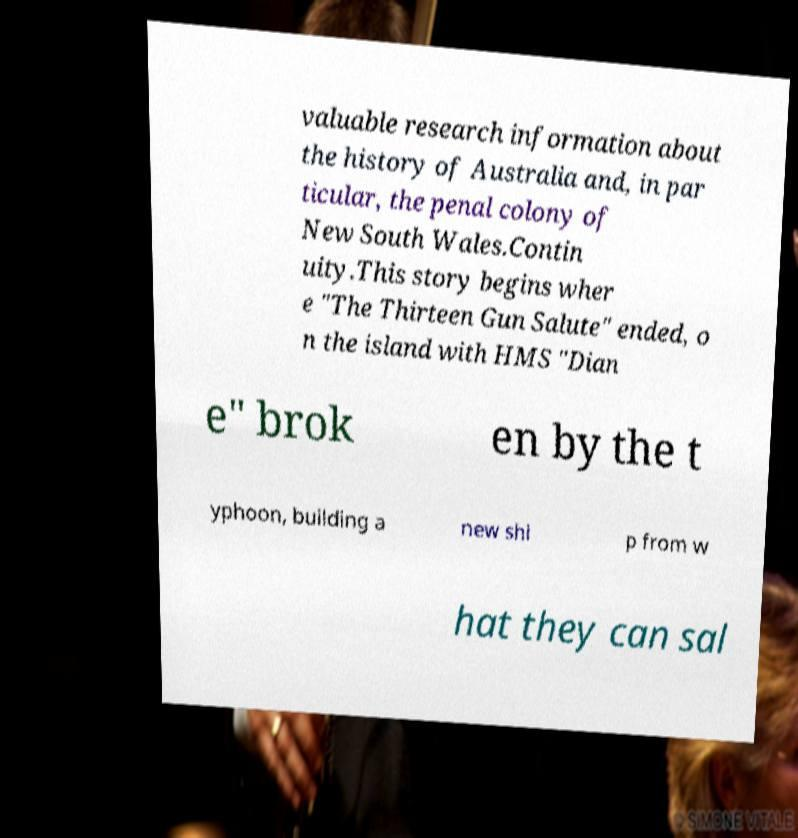For documentation purposes, I need the text within this image transcribed. Could you provide that? valuable research information about the history of Australia and, in par ticular, the penal colony of New South Wales.Contin uity.This story begins wher e "The Thirteen Gun Salute" ended, o n the island with HMS "Dian e" brok en by the t yphoon, building a new shi p from w hat they can sal 